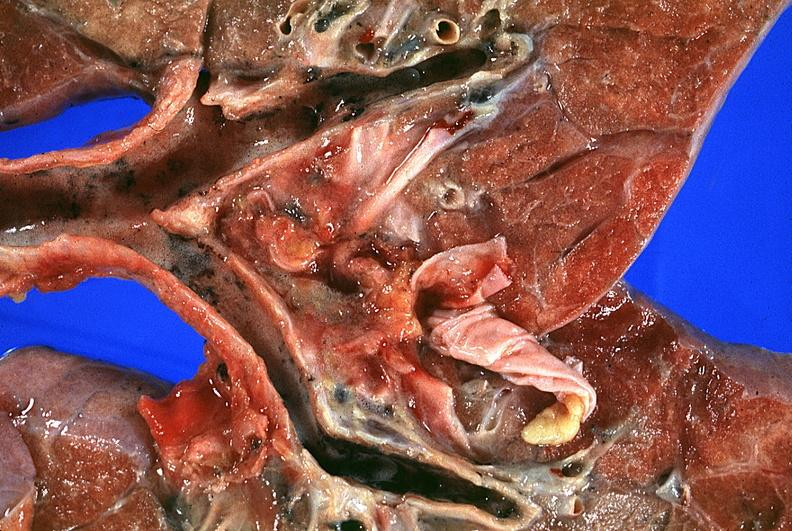where is this?
Answer the question using a single word or phrase. Lung 